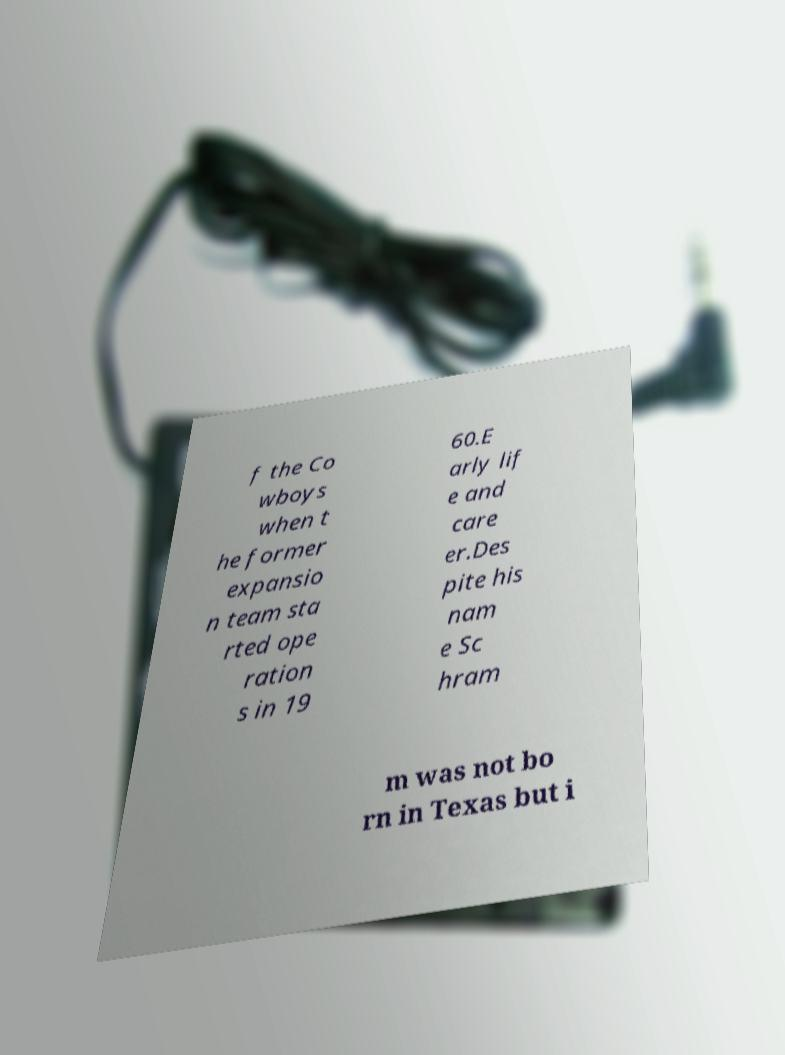Please read and relay the text visible in this image. What does it say? f the Co wboys when t he former expansio n team sta rted ope ration s in 19 60.E arly lif e and care er.Des pite his nam e Sc hram m was not bo rn in Texas but i 